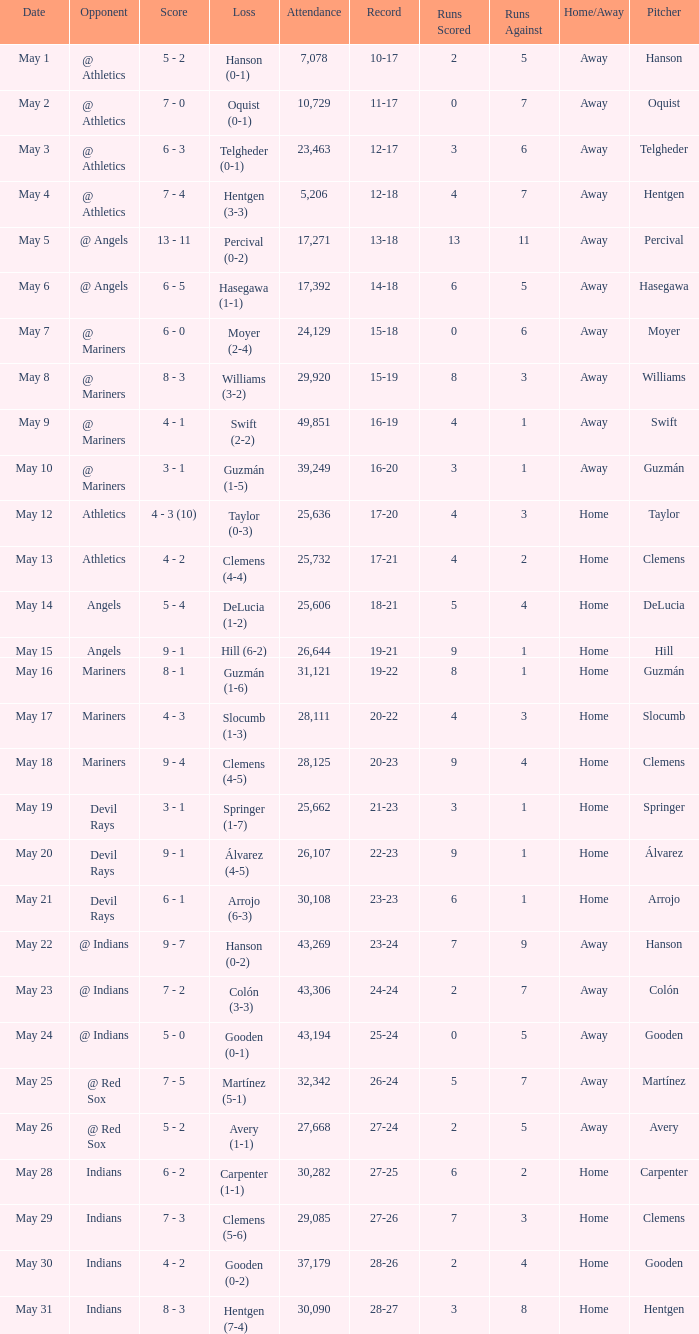Who lost on May 31? Hentgen (7-4). 